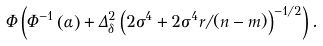Convert formula to latex. <formula><loc_0><loc_0><loc_500><loc_500>\Phi \left ( \Phi ^ { - 1 } \left ( \alpha \right ) + \Delta _ { \delta } ^ { 2 } \left ( 2 \sigma ^ { 4 } + 2 \sigma ^ { 4 } r / ( n - m ) \right ) ^ { - 1 / 2 } \right ) .</formula> 